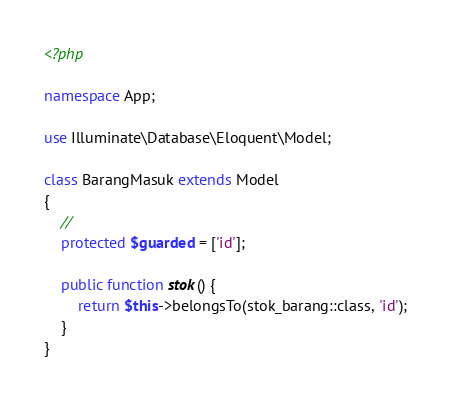Convert code to text. <code><loc_0><loc_0><loc_500><loc_500><_PHP_><?php

namespace App;

use Illuminate\Database\Eloquent\Model;

class BarangMasuk extends Model
{
    //
    protected $guarded = ['id'];

    public function stok() {
        return $this->belongsTo(stok_barang::class, 'id');
    }
}
</code> 